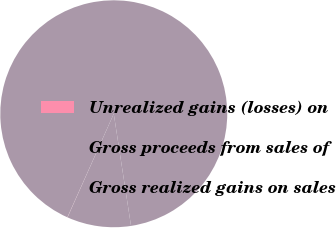Convert chart. <chart><loc_0><loc_0><loc_500><loc_500><pie_chart><fcel>Unrealized gains (losses) on<fcel>Gross proceeds from sales of<fcel>Gross realized gains on sales<nl><fcel>0.03%<fcel>90.86%<fcel>9.11%<nl></chart> 